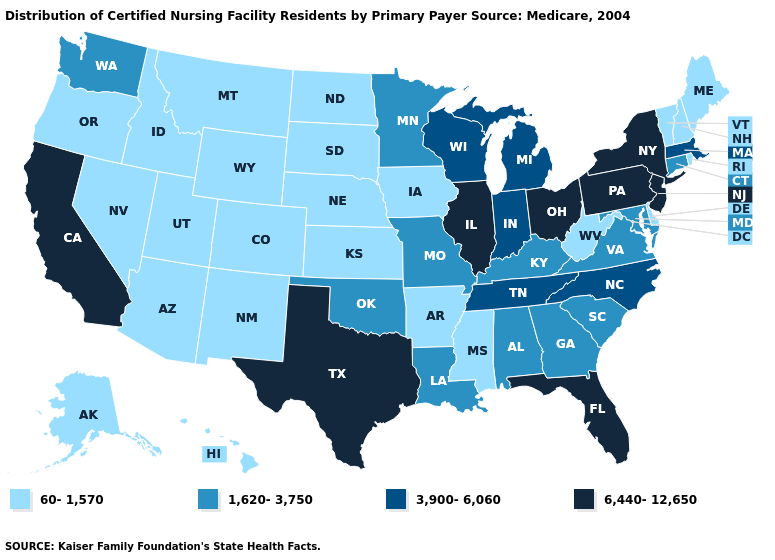Does the first symbol in the legend represent the smallest category?
Give a very brief answer. Yes. Which states have the lowest value in the USA?
Keep it brief. Alaska, Arizona, Arkansas, Colorado, Delaware, Hawaii, Idaho, Iowa, Kansas, Maine, Mississippi, Montana, Nebraska, Nevada, New Hampshire, New Mexico, North Dakota, Oregon, Rhode Island, South Dakota, Utah, Vermont, West Virginia, Wyoming. Name the states that have a value in the range 1,620-3,750?
Give a very brief answer. Alabama, Connecticut, Georgia, Kentucky, Louisiana, Maryland, Minnesota, Missouri, Oklahoma, South Carolina, Virginia, Washington. Name the states that have a value in the range 60-1,570?
Write a very short answer. Alaska, Arizona, Arkansas, Colorado, Delaware, Hawaii, Idaho, Iowa, Kansas, Maine, Mississippi, Montana, Nebraska, Nevada, New Hampshire, New Mexico, North Dakota, Oregon, Rhode Island, South Dakota, Utah, Vermont, West Virginia, Wyoming. Which states have the lowest value in the South?
Give a very brief answer. Arkansas, Delaware, Mississippi, West Virginia. Does Mississippi have the lowest value in the USA?
Concise answer only. Yes. Among the states that border North Dakota , does Minnesota have the lowest value?
Quick response, please. No. What is the highest value in states that border North Carolina?
Be succinct. 3,900-6,060. Does New Jersey have the highest value in the USA?
Keep it brief. Yes. What is the lowest value in the USA?
Answer briefly. 60-1,570. Name the states that have a value in the range 6,440-12,650?
Answer briefly. California, Florida, Illinois, New Jersey, New York, Ohio, Pennsylvania, Texas. Among the states that border Michigan , does Ohio have the lowest value?
Short answer required. No. Which states have the lowest value in the USA?
Quick response, please. Alaska, Arizona, Arkansas, Colorado, Delaware, Hawaii, Idaho, Iowa, Kansas, Maine, Mississippi, Montana, Nebraska, Nevada, New Hampshire, New Mexico, North Dakota, Oregon, Rhode Island, South Dakota, Utah, Vermont, West Virginia, Wyoming. 